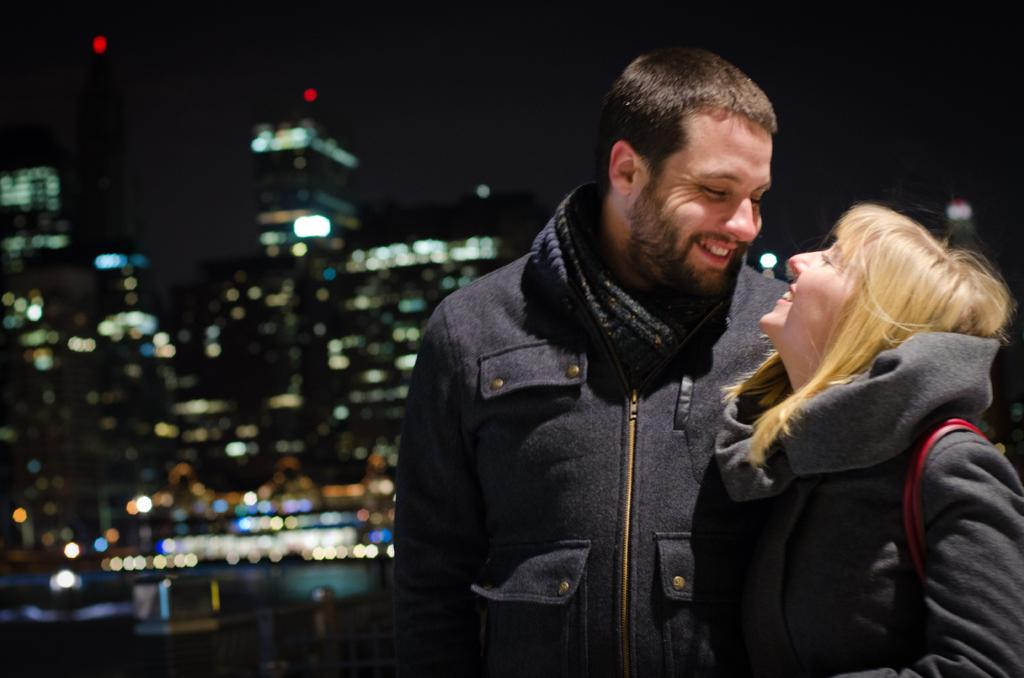What type of structures are located on the left side of the image? There are big buildings on the left side of the image. What is happening on the right side of the image? A man is standing on the right side of the image, and a woman is looking at him. How is the man feeling in the image? The man is smiling, which suggests he is feeling happy or content. What is the man wearing in the image? The man is wearing a coat. What type of letters is the man holding in the image? There are no letters present in the image; the man is not holding anything. What instrument is the woman playing in the image? There is no guitar or any musical instrument present in the image. 